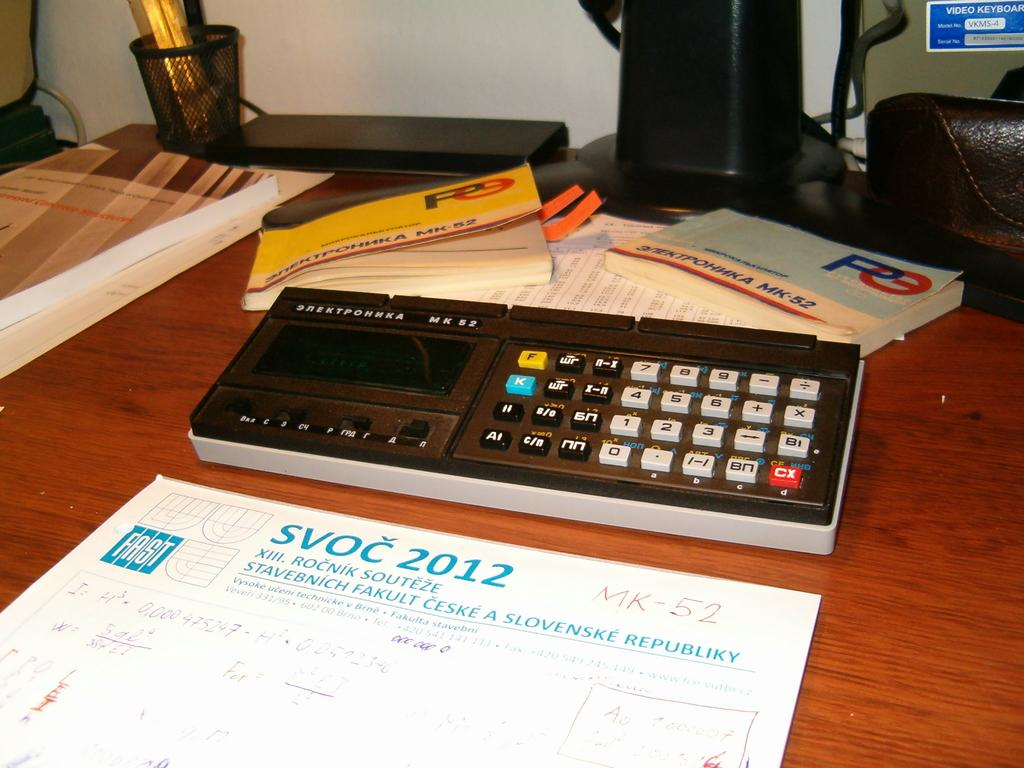<image>
Relay a brief, clear account of the picture shown. The SVOC calendar for 2012 is set on the desk. 